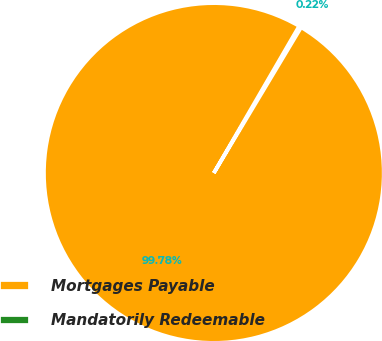<chart> <loc_0><loc_0><loc_500><loc_500><pie_chart><fcel>Mortgages Payable<fcel>Mandatorily Redeemable<nl><fcel>99.78%<fcel>0.22%<nl></chart> 